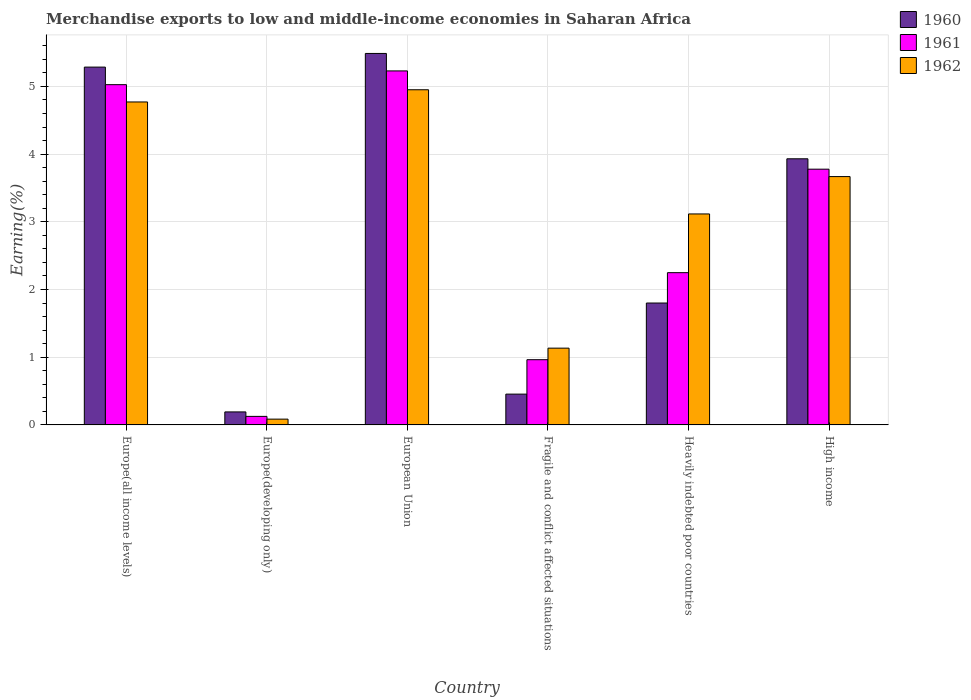Are the number of bars on each tick of the X-axis equal?
Your response must be concise. Yes. How many bars are there on the 5th tick from the left?
Make the answer very short. 3. How many bars are there on the 3rd tick from the right?
Make the answer very short. 3. What is the percentage of amount earned from merchandise exports in 1960 in High income?
Your answer should be very brief. 3.93. Across all countries, what is the maximum percentage of amount earned from merchandise exports in 1960?
Provide a succinct answer. 5.49. Across all countries, what is the minimum percentage of amount earned from merchandise exports in 1962?
Offer a very short reply. 0.09. In which country was the percentage of amount earned from merchandise exports in 1960 maximum?
Your response must be concise. European Union. In which country was the percentage of amount earned from merchandise exports in 1961 minimum?
Ensure brevity in your answer.  Europe(developing only). What is the total percentage of amount earned from merchandise exports in 1960 in the graph?
Offer a terse response. 17.15. What is the difference between the percentage of amount earned from merchandise exports in 1962 in Europe(developing only) and that in European Union?
Provide a short and direct response. -4.87. What is the difference between the percentage of amount earned from merchandise exports in 1962 in European Union and the percentage of amount earned from merchandise exports in 1961 in Heavily indebted poor countries?
Give a very brief answer. 2.7. What is the average percentage of amount earned from merchandise exports in 1962 per country?
Your answer should be compact. 2.95. What is the difference between the percentage of amount earned from merchandise exports of/in 1961 and percentage of amount earned from merchandise exports of/in 1960 in Heavily indebted poor countries?
Your answer should be very brief. 0.45. What is the ratio of the percentage of amount earned from merchandise exports in 1960 in Europe(developing only) to that in Heavily indebted poor countries?
Your answer should be very brief. 0.11. Is the difference between the percentage of amount earned from merchandise exports in 1961 in European Union and High income greater than the difference between the percentage of amount earned from merchandise exports in 1960 in European Union and High income?
Your answer should be compact. No. What is the difference between the highest and the second highest percentage of amount earned from merchandise exports in 1961?
Your answer should be very brief. 1.25. What is the difference between the highest and the lowest percentage of amount earned from merchandise exports in 1962?
Your answer should be compact. 4.87. In how many countries, is the percentage of amount earned from merchandise exports in 1960 greater than the average percentage of amount earned from merchandise exports in 1960 taken over all countries?
Your answer should be compact. 3. What does the 3rd bar from the left in Europe(all income levels) represents?
Make the answer very short. 1962. How many countries are there in the graph?
Keep it short and to the point. 6. Are the values on the major ticks of Y-axis written in scientific E-notation?
Offer a terse response. No. Where does the legend appear in the graph?
Offer a terse response. Top right. How many legend labels are there?
Your response must be concise. 3. What is the title of the graph?
Ensure brevity in your answer.  Merchandise exports to low and middle-income economies in Saharan Africa. What is the label or title of the Y-axis?
Provide a short and direct response. Earning(%). What is the Earning(%) of 1960 in Europe(all income levels)?
Provide a short and direct response. 5.29. What is the Earning(%) in 1961 in Europe(all income levels)?
Your response must be concise. 5.03. What is the Earning(%) in 1962 in Europe(all income levels)?
Your response must be concise. 4.77. What is the Earning(%) of 1960 in Europe(developing only)?
Give a very brief answer. 0.19. What is the Earning(%) of 1961 in Europe(developing only)?
Offer a very short reply. 0.13. What is the Earning(%) in 1962 in Europe(developing only)?
Give a very brief answer. 0.09. What is the Earning(%) of 1960 in European Union?
Your answer should be compact. 5.49. What is the Earning(%) of 1961 in European Union?
Your answer should be very brief. 5.23. What is the Earning(%) of 1962 in European Union?
Offer a terse response. 4.95. What is the Earning(%) in 1960 in Fragile and conflict affected situations?
Provide a succinct answer. 0.45. What is the Earning(%) of 1961 in Fragile and conflict affected situations?
Your response must be concise. 0.96. What is the Earning(%) of 1962 in Fragile and conflict affected situations?
Your response must be concise. 1.13. What is the Earning(%) of 1960 in Heavily indebted poor countries?
Your answer should be compact. 1.8. What is the Earning(%) in 1961 in Heavily indebted poor countries?
Your answer should be very brief. 2.25. What is the Earning(%) of 1962 in Heavily indebted poor countries?
Your answer should be very brief. 3.12. What is the Earning(%) of 1960 in High income?
Offer a terse response. 3.93. What is the Earning(%) of 1961 in High income?
Your response must be concise. 3.78. What is the Earning(%) in 1962 in High income?
Give a very brief answer. 3.67. Across all countries, what is the maximum Earning(%) of 1960?
Ensure brevity in your answer.  5.49. Across all countries, what is the maximum Earning(%) in 1961?
Your answer should be very brief. 5.23. Across all countries, what is the maximum Earning(%) of 1962?
Provide a succinct answer. 4.95. Across all countries, what is the minimum Earning(%) of 1960?
Give a very brief answer. 0.19. Across all countries, what is the minimum Earning(%) in 1961?
Make the answer very short. 0.13. Across all countries, what is the minimum Earning(%) in 1962?
Your answer should be compact. 0.09. What is the total Earning(%) of 1960 in the graph?
Offer a terse response. 17.15. What is the total Earning(%) in 1961 in the graph?
Your answer should be compact. 17.37. What is the total Earning(%) of 1962 in the graph?
Offer a very short reply. 17.72. What is the difference between the Earning(%) of 1960 in Europe(all income levels) and that in Europe(developing only)?
Offer a very short reply. 5.09. What is the difference between the Earning(%) in 1961 in Europe(all income levels) and that in Europe(developing only)?
Your response must be concise. 4.9. What is the difference between the Earning(%) in 1962 in Europe(all income levels) and that in Europe(developing only)?
Ensure brevity in your answer.  4.68. What is the difference between the Earning(%) in 1960 in Europe(all income levels) and that in European Union?
Your response must be concise. -0.2. What is the difference between the Earning(%) of 1961 in Europe(all income levels) and that in European Union?
Your answer should be compact. -0.2. What is the difference between the Earning(%) of 1962 in Europe(all income levels) and that in European Union?
Provide a short and direct response. -0.18. What is the difference between the Earning(%) of 1960 in Europe(all income levels) and that in Fragile and conflict affected situations?
Provide a succinct answer. 4.83. What is the difference between the Earning(%) of 1961 in Europe(all income levels) and that in Fragile and conflict affected situations?
Make the answer very short. 4.06. What is the difference between the Earning(%) in 1962 in Europe(all income levels) and that in Fragile and conflict affected situations?
Offer a terse response. 3.64. What is the difference between the Earning(%) in 1960 in Europe(all income levels) and that in Heavily indebted poor countries?
Provide a succinct answer. 3.48. What is the difference between the Earning(%) in 1961 in Europe(all income levels) and that in Heavily indebted poor countries?
Offer a very short reply. 2.78. What is the difference between the Earning(%) of 1962 in Europe(all income levels) and that in Heavily indebted poor countries?
Ensure brevity in your answer.  1.65. What is the difference between the Earning(%) in 1960 in Europe(all income levels) and that in High income?
Your answer should be very brief. 1.35. What is the difference between the Earning(%) in 1961 in Europe(all income levels) and that in High income?
Your answer should be very brief. 1.25. What is the difference between the Earning(%) of 1962 in Europe(all income levels) and that in High income?
Give a very brief answer. 1.1. What is the difference between the Earning(%) of 1960 in Europe(developing only) and that in European Union?
Your answer should be compact. -5.29. What is the difference between the Earning(%) of 1961 in Europe(developing only) and that in European Union?
Ensure brevity in your answer.  -5.1. What is the difference between the Earning(%) of 1962 in Europe(developing only) and that in European Union?
Provide a short and direct response. -4.87. What is the difference between the Earning(%) of 1960 in Europe(developing only) and that in Fragile and conflict affected situations?
Offer a very short reply. -0.26. What is the difference between the Earning(%) in 1961 in Europe(developing only) and that in Fragile and conflict affected situations?
Your answer should be compact. -0.84. What is the difference between the Earning(%) of 1962 in Europe(developing only) and that in Fragile and conflict affected situations?
Provide a succinct answer. -1.05. What is the difference between the Earning(%) in 1960 in Europe(developing only) and that in Heavily indebted poor countries?
Provide a succinct answer. -1.61. What is the difference between the Earning(%) of 1961 in Europe(developing only) and that in Heavily indebted poor countries?
Make the answer very short. -2.12. What is the difference between the Earning(%) in 1962 in Europe(developing only) and that in Heavily indebted poor countries?
Give a very brief answer. -3.03. What is the difference between the Earning(%) of 1960 in Europe(developing only) and that in High income?
Your answer should be compact. -3.74. What is the difference between the Earning(%) of 1961 in Europe(developing only) and that in High income?
Ensure brevity in your answer.  -3.65. What is the difference between the Earning(%) of 1962 in Europe(developing only) and that in High income?
Offer a very short reply. -3.58. What is the difference between the Earning(%) in 1960 in European Union and that in Fragile and conflict affected situations?
Offer a very short reply. 5.03. What is the difference between the Earning(%) of 1961 in European Union and that in Fragile and conflict affected situations?
Offer a terse response. 4.27. What is the difference between the Earning(%) of 1962 in European Union and that in Fragile and conflict affected situations?
Ensure brevity in your answer.  3.82. What is the difference between the Earning(%) of 1960 in European Union and that in Heavily indebted poor countries?
Your answer should be compact. 3.69. What is the difference between the Earning(%) in 1961 in European Union and that in Heavily indebted poor countries?
Make the answer very short. 2.98. What is the difference between the Earning(%) in 1962 in European Union and that in Heavily indebted poor countries?
Provide a short and direct response. 1.83. What is the difference between the Earning(%) of 1960 in European Union and that in High income?
Give a very brief answer. 1.56. What is the difference between the Earning(%) of 1961 in European Union and that in High income?
Offer a very short reply. 1.45. What is the difference between the Earning(%) of 1962 in European Union and that in High income?
Your answer should be very brief. 1.28. What is the difference between the Earning(%) of 1960 in Fragile and conflict affected situations and that in Heavily indebted poor countries?
Offer a terse response. -1.35. What is the difference between the Earning(%) in 1961 in Fragile and conflict affected situations and that in Heavily indebted poor countries?
Provide a short and direct response. -1.29. What is the difference between the Earning(%) in 1962 in Fragile and conflict affected situations and that in Heavily indebted poor countries?
Provide a short and direct response. -1.98. What is the difference between the Earning(%) in 1960 in Fragile and conflict affected situations and that in High income?
Make the answer very short. -3.48. What is the difference between the Earning(%) in 1961 in Fragile and conflict affected situations and that in High income?
Your answer should be very brief. -2.81. What is the difference between the Earning(%) in 1962 in Fragile and conflict affected situations and that in High income?
Keep it short and to the point. -2.53. What is the difference between the Earning(%) in 1960 in Heavily indebted poor countries and that in High income?
Your response must be concise. -2.13. What is the difference between the Earning(%) in 1961 in Heavily indebted poor countries and that in High income?
Make the answer very short. -1.53. What is the difference between the Earning(%) of 1962 in Heavily indebted poor countries and that in High income?
Make the answer very short. -0.55. What is the difference between the Earning(%) in 1960 in Europe(all income levels) and the Earning(%) in 1961 in Europe(developing only)?
Provide a short and direct response. 5.16. What is the difference between the Earning(%) of 1960 in Europe(all income levels) and the Earning(%) of 1962 in Europe(developing only)?
Keep it short and to the point. 5.2. What is the difference between the Earning(%) in 1961 in Europe(all income levels) and the Earning(%) in 1962 in Europe(developing only)?
Ensure brevity in your answer.  4.94. What is the difference between the Earning(%) of 1960 in Europe(all income levels) and the Earning(%) of 1961 in European Union?
Your answer should be compact. 0.06. What is the difference between the Earning(%) in 1960 in Europe(all income levels) and the Earning(%) in 1962 in European Union?
Keep it short and to the point. 0.33. What is the difference between the Earning(%) in 1961 in Europe(all income levels) and the Earning(%) in 1962 in European Union?
Make the answer very short. 0.08. What is the difference between the Earning(%) in 1960 in Europe(all income levels) and the Earning(%) in 1961 in Fragile and conflict affected situations?
Provide a succinct answer. 4.32. What is the difference between the Earning(%) in 1960 in Europe(all income levels) and the Earning(%) in 1962 in Fragile and conflict affected situations?
Give a very brief answer. 4.15. What is the difference between the Earning(%) in 1961 in Europe(all income levels) and the Earning(%) in 1962 in Fragile and conflict affected situations?
Make the answer very short. 3.89. What is the difference between the Earning(%) in 1960 in Europe(all income levels) and the Earning(%) in 1961 in Heavily indebted poor countries?
Ensure brevity in your answer.  3.04. What is the difference between the Earning(%) of 1960 in Europe(all income levels) and the Earning(%) of 1962 in Heavily indebted poor countries?
Your response must be concise. 2.17. What is the difference between the Earning(%) in 1961 in Europe(all income levels) and the Earning(%) in 1962 in Heavily indebted poor countries?
Provide a short and direct response. 1.91. What is the difference between the Earning(%) in 1960 in Europe(all income levels) and the Earning(%) in 1961 in High income?
Offer a very short reply. 1.51. What is the difference between the Earning(%) of 1960 in Europe(all income levels) and the Earning(%) of 1962 in High income?
Your response must be concise. 1.62. What is the difference between the Earning(%) of 1961 in Europe(all income levels) and the Earning(%) of 1962 in High income?
Provide a succinct answer. 1.36. What is the difference between the Earning(%) of 1960 in Europe(developing only) and the Earning(%) of 1961 in European Union?
Keep it short and to the point. -5.04. What is the difference between the Earning(%) of 1960 in Europe(developing only) and the Earning(%) of 1962 in European Union?
Ensure brevity in your answer.  -4.76. What is the difference between the Earning(%) of 1961 in Europe(developing only) and the Earning(%) of 1962 in European Union?
Offer a very short reply. -4.82. What is the difference between the Earning(%) in 1960 in Europe(developing only) and the Earning(%) in 1961 in Fragile and conflict affected situations?
Provide a succinct answer. -0.77. What is the difference between the Earning(%) in 1960 in Europe(developing only) and the Earning(%) in 1962 in Fragile and conflict affected situations?
Provide a succinct answer. -0.94. What is the difference between the Earning(%) in 1961 in Europe(developing only) and the Earning(%) in 1962 in Fragile and conflict affected situations?
Your answer should be very brief. -1.01. What is the difference between the Earning(%) in 1960 in Europe(developing only) and the Earning(%) in 1961 in Heavily indebted poor countries?
Give a very brief answer. -2.06. What is the difference between the Earning(%) of 1960 in Europe(developing only) and the Earning(%) of 1962 in Heavily indebted poor countries?
Ensure brevity in your answer.  -2.92. What is the difference between the Earning(%) in 1961 in Europe(developing only) and the Earning(%) in 1962 in Heavily indebted poor countries?
Your answer should be very brief. -2.99. What is the difference between the Earning(%) of 1960 in Europe(developing only) and the Earning(%) of 1961 in High income?
Give a very brief answer. -3.59. What is the difference between the Earning(%) of 1960 in Europe(developing only) and the Earning(%) of 1962 in High income?
Keep it short and to the point. -3.48. What is the difference between the Earning(%) in 1961 in Europe(developing only) and the Earning(%) in 1962 in High income?
Your answer should be compact. -3.54. What is the difference between the Earning(%) in 1960 in European Union and the Earning(%) in 1961 in Fragile and conflict affected situations?
Your response must be concise. 4.52. What is the difference between the Earning(%) of 1960 in European Union and the Earning(%) of 1962 in Fragile and conflict affected situations?
Your response must be concise. 4.35. What is the difference between the Earning(%) in 1961 in European Union and the Earning(%) in 1962 in Fragile and conflict affected situations?
Make the answer very short. 4.1. What is the difference between the Earning(%) in 1960 in European Union and the Earning(%) in 1961 in Heavily indebted poor countries?
Give a very brief answer. 3.24. What is the difference between the Earning(%) of 1960 in European Union and the Earning(%) of 1962 in Heavily indebted poor countries?
Offer a terse response. 2.37. What is the difference between the Earning(%) in 1961 in European Union and the Earning(%) in 1962 in Heavily indebted poor countries?
Your answer should be very brief. 2.11. What is the difference between the Earning(%) of 1960 in European Union and the Earning(%) of 1961 in High income?
Your answer should be compact. 1.71. What is the difference between the Earning(%) of 1960 in European Union and the Earning(%) of 1962 in High income?
Ensure brevity in your answer.  1.82. What is the difference between the Earning(%) in 1961 in European Union and the Earning(%) in 1962 in High income?
Your response must be concise. 1.56. What is the difference between the Earning(%) in 1960 in Fragile and conflict affected situations and the Earning(%) in 1961 in Heavily indebted poor countries?
Give a very brief answer. -1.79. What is the difference between the Earning(%) in 1960 in Fragile and conflict affected situations and the Earning(%) in 1962 in Heavily indebted poor countries?
Offer a very short reply. -2.66. What is the difference between the Earning(%) in 1961 in Fragile and conflict affected situations and the Earning(%) in 1962 in Heavily indebted poor countries?
Offer a very short reply. -2.15. What is the difference between the Earning(%) in 1960 in Fragile and conflict affected situations and the Earning(%) in 1961 in High income?
Provide a short and direct response. -3.32. What is the difference between the Earning(%) in 1960 in Fragile and conflict affected situations and the Earning(%) in 1962 in High income?
Provide a succinct answer. -3.21. What is the difference between the Earning(%) in 1961 in Fragile and conflict affected situations and the Earning(%) in 1962 in High income?
Your answer should be very brief. -2.7. What is the difference between the Earning(%) of 1960 in Heavily indebted poor countries and the Earning(%) of 1961 in High income?
Give a very brief answer. -1.98. What is the difference between the Earning(%) of 1960 in Heavily indebted poor countries and the Earning(%) of 1962 in High income?
Ensure brevity in your answer.  -1.87. What is the difference between the Earning(%) of 1961 in Heavily indebted poor countries and the Earning(%) of 1962 in High income?
Ensure brevity in your answer.  -1.42. What is the average Earning(%) in 1960 per country?
Your answer should be compact. 2.86. What is the average Earning(%) of 1961 per country?
Ensure brevity in your answer.  2.9. What is the average Earning(%) of 1962 per country?
Your answer should be very brief. 2.95. What is the difference between the Earning(%) in 1960 and Earning(%) in 1961 in Europe(all income levels)?
Offer a very short reply. 0.26. What is the difference between the Earning(%) in 1960 and Earning(%) in 1962 in Europe(all income levels)?
Provide a succinct answer. 0.52. What is the difference between the Earning(%) of 1961 and Earning(%) of 1962 in Europe(all income levels)?
Offer a very short reply. 0.26. What is the difference between the Earning(%) in 1960 and Earning(%) in 1961 in Europe(developing only)?
Provide a short and direct response. 0.07. What is the difference between the Earning(%) in 1960 and Earning(%) in 1962 in Europe(developing only)?
Give a very brief answer. 0.11. What is the difference between the Earning(%) in 1961 and Earning(%) in 1962 in Europe(developing only)?
Keep it short and to the point. 0.04. What is the difference between the Earning(%) of 1960 and Earning(%) of 1961 in European Union?
Provide a short and direct response. 0.26. What is the difference between the Earning(%) of 1960 and Earning(%) of 1962 in European Union?
Make the answer very short. 0.54. What is the difference between the Earning(%) in 1961 and Earning(%) in 1962 in European Union?
Keep it short and to the point. 0.28. What is the difference between the Earning(%) of 1960 and Earning(%) of 1961 in Fragile and conflict affected situations?
Make the answer very short. -0.51. What is the difference between the Earning(%) of 1960 and Earning(%) of 1962 in Fragile and conflict affected situations?
Offer a very short reply. -0.68. What is the difference between the Earning(%) of 1961 and Earning(%) of 1962 in Fragile and conflict affected situations?
Provide a succinct answer. -0.17. What is the difference between the Earning(%) of 1960 and Earning(%) of 1961 in Heavily indebted poor countries?
Ensure brevity in your answer.  -0.45. What is the difference between the Earning(%) of 1960 and Earning(%) of 1962 in Heavily indebted poor countries?
Provide a short and direct response. -1.32. What is the difference between the Earning(%) in 1961 and Earning(%) in 1962 in Heavily indebted poor countries?
Provide a short and direct response. -0.87. What is the difference between the Earning(%) in 1960 and Earning(%) in 1961 in High income?
Your answer should be compact. 0.15. What is the difference between the Earning(%) in 1960 and Earning(%) in 1962 in High income?
Keep it short and to the point. 0.26. What is the difference between the Earning(%) of 1961 and Earning(%) of 1962 in High income?
Offer a very short reply. 0.11. What is the ratio of the Earning(%) of 1960 in Europe(all income levels) to that in Europe(developing only)?
Your answer should be compact. 27.54. What is the ratio of the Earning(%) of 1961 in Europe(all income levels) to that in Europe(developing only)?
Keep it short and to the point. 39.9. What is the ratio of the Earning(%) in 1962 in Europe(all income levels) to that in Europe(developing only)?
Offer a very short reply. 55.85. What is the ratio of the Earning(%) in 1960 in Europe(all income levels) to that in European Union?
Provide a short and direct response. 0.96. What is the ratio of the Earning(%) of 1961 in Europe(all income levels) to that in European Union?
Your answer should be compact. 0.96. What is the ratio of the Earning(%) of 1962 in Europe(all income levels) to that in European Union?
Offer a very short reply. 0.96. What is the ratio of the Earning(%) in 1960 in Europe(all income levels) to that in Fragile and conflict affected situations?
Give a very brief answer. 11.62. What is the ratio of the Earning(%) of 1961 in Europe(all income levels) to that in Fragile and conflict affected situations?
Provide a succinct answer. 5.22. What is the ratio of the Earning(%) of 1962 in Europe(all income levels) to that in Fragile and conflict affected situations?
Your answer should be very brief. 4.21. What is the ratio of the Earning(%) of 1960 in Europe(all income levels) to that in Heavily indebted poor countries?
Provide a short and direct response. 2.94. What is the ratio of the Earning(%) in 1961 in Europe(all income levels) to that in Heavily indebted poor countries?
Your answer should be very brief. 2.23. What is the ratio of the Earning(%) in 1962 in Europe(all income levels) to that in Heavily indebted poor countries?
Keep it short and to the point. 1.53. What is the ratio of the Earning(%) of 1960 in Europe(all income levels) to that in High income?
Keep it short and to the point. 1.34. What is the ratio of the Earning(%) of 1961 in Europe(all income levels) to that in High income?
Keep it short and to the point. 1.33. What is the ratio of the Earning(%) in 1962 in Europe(all income levels) to that in High income?
Offer a terse response. 1.3. What is the ratio of the Earning(%) in 1960 in Europe(developing only) to that in European Union?
Provide a short and direct response. 0.04. What is the ratio of the Earning(%) in 1961 in Europe(developing only) to that in European Union?
Provide a succinct answer. 0.02. What is the ratio of the Earning(%) of 1962 in Europe(developing only) to that in European Union?
Provide a short and direct response. 0.02. What is the ratio of the Earning(%) of 1960 in Europe(developing only) to that in Fragile and conflict affected situations?
Your answer should be very brief. 0.42. What is the ratio of the Earning(%) of 1961 in Europe(developing only) to that in Fragile and conflict affected situations?
Your response must be concise. 0.13. What is the ratio of the Earning(%) of 1962 in Europe(developing only) to that in Fragile and conflict affected situations?
Provide a succinct answer. 0.08. What is the ratio of the Earning(%) of 1960 in Europe(developing only) to that in Heavily indebted poor countries?
Make the answer very short. 0.11. What is the ratio of the Earning(%) of 1961 in Europe(developing only) to that in Heavily indebted poor countries?
Provide a succinct answer. 0.06. What is the ratio of the Earning(%) in 1962 in Europe(developing only) to that in Heavily indebted poor countries?
Keep it short and to the point. 0.03. What is the ratio of the Earning(%) of 1960 in Europe(developing only) to that in High income?
Ensure brevity in your answer.  0.05. What is the ratio of the Earning(%) of 1962 in Europe(developing only) to that in High income?
Provide a succinct answer. 0.02. What is the ratio of the Earning(%) of 1960 in European Union to that in Fragile and conflict affected situations?
Keep it short and to the point. 12.06. What is the ratio of the Earning(%) of 1961 in European Union to that in Fragile and conflict affected situations?
Keep it short and to the point. 5.43. What is the ratio of the Earning(%) in 1962 in European Union to that in Fragile and conflict affected situations?
Your answer should be very brief. 4.37. What is the ratio of the Earning(%) of 1960 in European Union to that in Heavily indebted poor countries?
Provide a short and direct response. 3.05. What is the ratio of the Earning(%) of 1961 in European Union to that in Heavily indebted poor countries?
Provide a succinct answer. 2.33. What is the ratio of the Earning(%) in 1962 in European Union to that in Heavily indebted poor countries?
Offer a very short reply. 1.59. What is the ratio of the Earning(%) of 1960 in European Union to that in High income?
Your response must be concise. 1.4. What is the ratio of the Earning(%) of 1961 in European Union to that in High income?
Offer a very short reply. 1.38. What is the ratio of the Earning(%) of 1962 in European Union to that in High income?
Offer a terse response. 1.35. What is the ratio of the Earning(%) of 1960 in Fragile and conflict affected situations to that in Heavily indebted poor countries?
Your answer should be compact. 0.25. What is the ratio of the Earning(%) in 1961 in Fragile and conflict affected situations to that in Heavily indebted poor countries?
Offer a very short reply. 0.43. What is the ratio of the Earning(%) in 1962 in Fragile and conflict affected situations to that in Heavily indebted poor countries?
Keep it short and to the point. 0.36. What is the ratio of the Earning(%) of 1960 in Fragile and conflict affected situations to that in High income?
Ensure brevity in your answer.  0.12. What is the ratio of the Earning(%) of 1961 in Fragile and conflict affected situations to that in High income?
Give a very brief answer. 0.26. What is the ratio of the Earning(%) of 1962 in Fragile and conflict affected situations to that in High income?
Ensure brevity in your answer.  0.31. What is the ratio of the Earning(%) in 1960 in Heavily indebted poor countries to that in High income?
Ensure brevity in your answer.  0.46. What is the ratio of the Earning(%) of 1961 in Heavily indebted poor countries to that in High income?
Make the answer very short. 0.6. What is the ratio of the Earning(%) of 1962 in Heavily indebted poor countries to that in High income?
Ensure brevity in your answer.  0.85. What is the difference between the highest and the second highest Earning(%) in 1960?
Provide a succinct answer. 0.2. What is the difference between the highest and the second highest Earning(%) in 1961?
Your answer should be very brief. 0.2. What is the difference between the highest and the second highest Earning(%) in 1962?
Your answer should be very brief. 0.18. What is the difference between the highest and the lowest Earning(%) of 1960?
Your answer should be very brief. 5.29. What is the difference between the highest and the lowest Earning(%) in 1961?
Offer a very short reply. 5.1. What is the difference between the highest and the lowest Earning(%) in 1962?
Your answer should be compact. 4.87. 